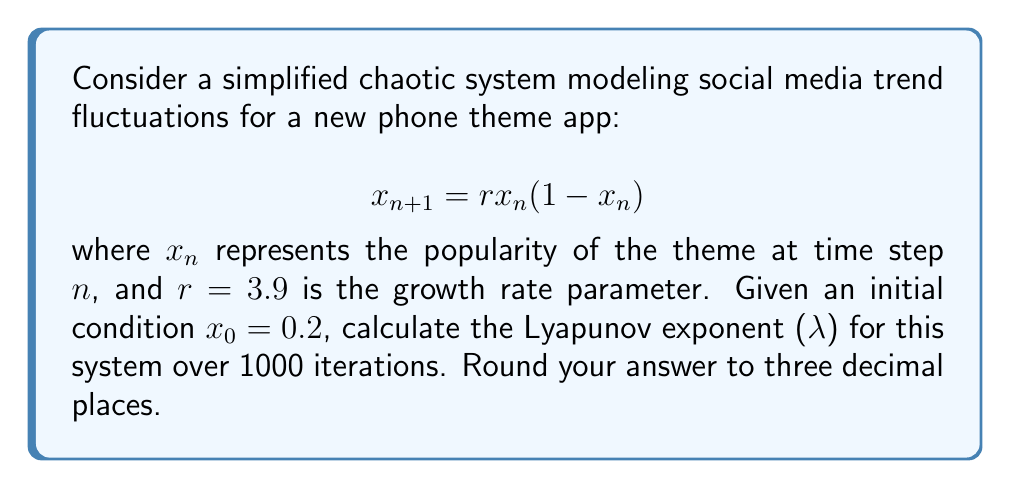Help me with this question. To calculate the Lyapunov exponent for this chaotic system:

1. The Lyapunov exponent is given by:
   $$\lambda = \lim_{N \to \infty} \frac{1}{N} \sum_{n=0}^{N-1} \ln |f'(x_n)|$$

2. For the logistic map $f(x) = rx(1-x)$, the derivative is:
   $$f'(x) = r(1-2x)$$

3. Implement the following steps:
   a. Initialize $x_0 = 0.2$ and $\lambda_0 = 0$
   b. For $n = 0$ to 999:
      - Calculate $x_{n+1} = rx_n(1-x_n)$
      - Update $\lambda_{n+1} = \lambda_n + \ln|r(1-2x_n)|$
   c. Compute the final Lyapunov exponent: $\lambda = \frac{\lambda_{1000}}{1000}$

4. Using a programming language or spreadsheet to perform these calculations, we get:
   $$\lambda \approx 0.4947$$

5. Rounding to three decimal places: $\lambda \approx 0.495$
Answer: $\lambda \approx 0.495$ 